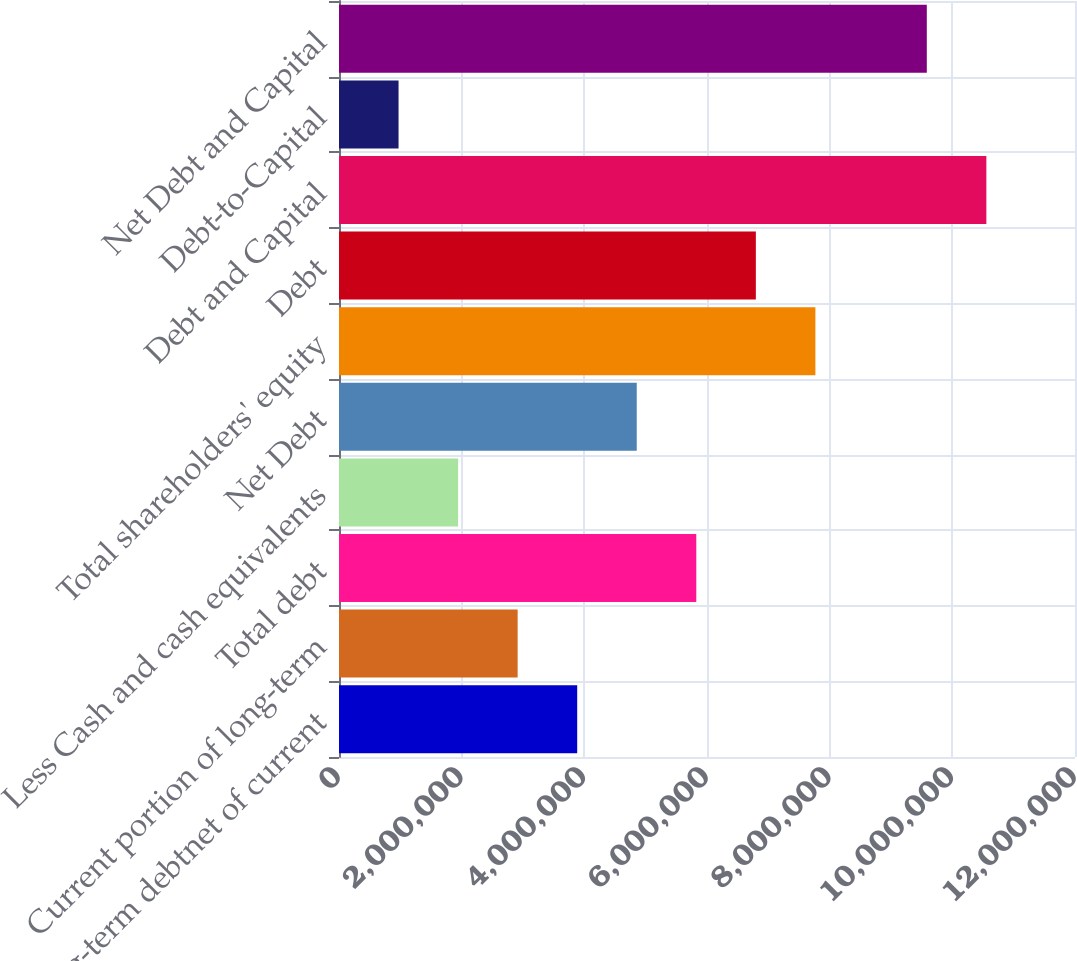Convert chart to OTSL. <chart><loc_0><loc_0><loc_500><loc_500><bar_chart><fcel>Long-term debtnet of current<fcel>Current portion of long-term<fcel>Total debt<fcel>Less Cash and cash equivalents<fcel>Net Debt<fcel>Total shareholders' equity<fcel>Debt<fcel>Debt and Capital<fcel>Debt-to-Capital<fcel>Net Debt and Capital<nl><fcel>3.88372e+06<fcel>2.9128e+06<fcel>5.82556e+06<fcel>1.94188e+06<fcel>4.85464e+06<fcel>7.7674e+06<fcel>6.79648e+06<fcel>1.05548e+07<fcel>970962<fcel>9.58386e+06<nl></chart> 